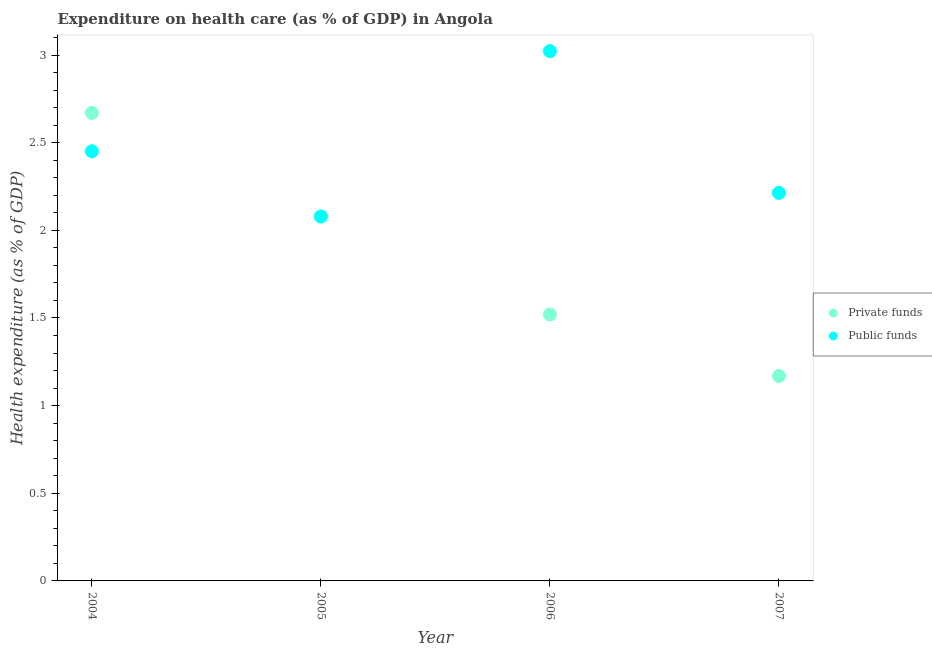How many different coloured dotlines are there?
Offer a very short reply. 2. What is the amount of private funds spent in healthcare in 2007?
Provide a succinct answer. 1.17. Across all years, what is the maximum amount of public funds spent in healthcare?
Make the answer very short. 3.02. Across all years, what is the minimum amount of private funds spent in healthcare?
Your answer should be very brief. 1.17. In which year was the amount of private funds spent in healthcare minimum?
Keep it short and to the point. 2007. What is the total amount of public funds spent in healthcare in the graph?
Offer a terse response. 9.77. What is the difference between the amount of private funds spent in healthcare in 2004 and that in 2005?
Give a very brief answer. 0.59. What is the difference between the amount of private funds spent in healthcare in 2007 and the amount of public funds spent in healthcare in 2004?
Keep it short and to the point. -1.28. What is the average amount of public funds spent in healthcare per year?
Keep it short and to the point. 2.44. In the year 2007, what is the difference between the amount of public funds spent in healthcare and amount of private funds spent in healthcare?
Give a very brief answer. 1.04. In how many years, is the amount of public funds spent in healthcare greater than 1.3 %?
Make the answer very short. 4. What is the ratio of the amount of public funds spent in healthcare in 2004 to that in 2005?
Your answer should be very brief. 1.18. Is the difference between the amount of public funds spent in healthcare in 2004 and 2006 greater than the difference between the amount of private funds spent in healthcare in 2004 and 2006?
Your answer should be compact. No. What is the difference between the highest and the second highest amount of private funds spent in healthcare?
Your answer should be very brief. 0.59. What is the difference between the highest and the lowest amount of private funds spent in healthcare?
Offer a very short reply. 1.5. Is the sum of the amount of public funds spent in healthcare in 2005 and 2006 greater than the maximum amount of private funds spent in healthcare across all years?
Offer a terse response. Yes. Is the amount of private funds spent in healthcare strictly less than the amount of public funds spent in healthcare over the years?
Keep it short and to the point. No. How many dotlines are there?
Offer a very short reply. 2. What is the difference between two consecutive major ticks on the Y-axis?
Offer a very short reply. 0.5. Does the graph contain grids?
Your answer should be compact. No. What is the title of the graph?
Ensure brevity in your answer.  Expenditure on health care (as % of GDP) in Angola. What is the label or title of the X-axis?
Ensure brevity in your answer.  Year. What is the label or title of the Y-axis?
Ensure brevity in your answer.  Health expenditure (as % of GDP). What is the Health expenditure (as % of GDP) in Private funds in 2004?
Your answer should be very brief. 2.67. What is the Health expenditure (as % of GDP) in Public funds in 2004?
Your answer should be compact. 2.45. What is the Health expenditure (as % of GDP) in Private funds in 2005?
Your answer should be compact. 2.08. What is the Health expenditure (as % of GDP) of Public funds in 2005?
Provide a succinct answer. 2.08. What is the Health expenditure (as % of GDP) in Private funds in 2006?
Give a very brief answer. 1.52. What is the Health expenditure (as % of GDP) of Public funds in 2006?
Your answer should be compact. 3.02. What is the Health expenditure (as % of GDP) in Private funds in 2007?
Your answer should be compact. 1.17. What is the Health expenditure (as % of GDP) in Public funds in 2007?
Provide a succinct answer. 2.21. Across all years, what is the maximum Health expenditure (as % of GDP) in Private funds?
Your answer should be compact. 2.67. Across all years, what is the maximum Health expenditure (as % of GDP) of Public funds?
Give a very brief answer. 3.02. Across all years, what is the minimum Health expenditure (as % of GDP) in Private funds?
Provide a succinct answer. 1.17. Across all years, what is the minimum Health expenditure (as % of GDP) of Public funds?
Provide a short and direct response. 2.08. What is the total Health expenditure (as % of GDP) in Private funds in the graph?
Offer a very short reply. 7.44. What is the total Health expenditure (as % of GDP) of Public funds in the graph?
Your response must be concise. 9.77. What is the difference between the Health expenditure (as % of GDP) of Private funds in 2004 and that in 2005?
Provide a short and direct response. 0.59. What is the difference between the Health expenditure (as % of GDP) of Public funds in 2004 and that in 2005?
Your answer should be very brief. 0.37. What is the difference between the Health expenditure (as % of GDP) in Private funds in 2004 and that in 2006?
Keep it short and to the point. 1.15. What is the difference between the Health expenditure (as % of GDP) of Public funds in 2004 and that in 2006?
Your answer should be very brief. -0.57. What is the difference between the Health expenditure (as % of GDP) in Private funds in 2004 and that in 2007?
Offer a very short reply. 1.5. What is the difference between the Health expenditure (as % of GDP) in Public funds in 2004 and that in 2007?
Your response must be concise. 0.24. What is the difference between the Health expenditure (as % of GDP) in Private funds in 2005 and that in 2006?
Make the answer very short. 0.56. What is the difference between the Health expenditure (as % of GDP) of Public funds in 2005 and that in 2006?
Provide a succinct answer. -0.94. What is the difference between the Health expenditure (as % of GDP) of Private funds in 2005 and that in 2007?
Provide a short and direct response. 0.91. What is the difference between the Health expenditure (as % of GDP) of Public funds in 2005 and that in 2007?
Your response must be concise. -0.13. What is the difference between the Health expenditure (as % of GDP) in Private funds in 2006 and that in 2007?
Provide a short and direct response. 0.35. What is the difference between the Health expenditure (as % of GDP) in Public funds in 2006 and that in 2007?
Provide a short and direct response. 0.81. What is the difference between the Health expenditure (as % of GDP) in Private funds in 2004 and the Health expenditure (as % of GDP) in Public funds in 2005?
Your answer should be compact. 0.59. What is the difference between the Health expenditure (as % of GDP) of Private funds in 2004 and the Health expenditure (as % of GDP) of Public funds in 2006?
Ensure brevity in your answer.  -0.35. What is the difference between the Health expenditure (as % of GDP) of Private funds in 2004 and the Health expenditure (as % of GDP) of Public funds in 2007?
Your answer should be compact. 0.46. What is the difference between the Health expenditure (as % of GDP) of Private funds in 2005 and the Health expenditure (as % of GDP) of Public funds in 2006?
Provide a succinct answer. -0.94. What is the difference between the Health expenditure (as % of GDP) of Private funds in 2005 and the Health expenditure (as % of GDP) of Public funds in 2007?
Make the answer very short. -0.13. What is the difference between the Health expenditure (as % of GDP) in Private funds in 2006 and the Health expenditure (as % of GDP) in Public funds in 2007?
Your answer should be compact. -0.69. What is the average Health expenditure (as % of GDP) in Private funds per year?
Make the answer very short. 1.86. What is the average Health expenditure (as % of GDP) of Public funds per year?
Offer a very short reply. 2.44. In the year 2004, what is the difference between the Health expenditure (as % of GDP) of Private funds and Health expenditure (as % of GDP) of Public funds?
Provide a short and direct response. 0.22. In the year 2006, what is the difference between the Health expenditure (as % of GDP) of Private funds and Health expenditure (as % of GDP) of Public funds?
Provide a succinct answer. -1.5. In the year 2007, what is the difference between the Health expenditure (as % of GDP) of Private funds and Health expenditure (as % of GDP) of Public funds?
Your response must be concise. -1.04. What is the ratio of the Health expenditure (as % of GDP) in Private funds in 2004 to that in 2005?
Your response must be concise. 1.28. What is the ratio of the Health expenditure (as % of GDP) of Public funds in 2004 to that in 2005?
Provide a short and direct response. 1.18. What is the ratio of the Health expenditure (as % of GDP) of Private funds in 2004 to that in 2006?
Make the answer very short. 1.76. What is the ratio of the Health expenditure (as % of GDP) of Public funds in 2004 to that in 2006?
Provide a short and direct response. 0.81. What is the ratio of the Health expenditure (as % of GDP) in Private funds in 2004 to that in 2007?
Ensure brevity in your answer.  2.28. What is the ratio of the Health expenditure (as % of GDP) of Public funds in 2004 to that in 2007?
Ensure brevity in your answer.  1.11. What is the ratio of the Health expenditure (as % of GDP) of Private funds in 2005 to that in 2006?
Offer a very short reply. 1.37. What is the ratio of the Health expenditure (as % of GDP) of Public funds in 2005 to that in 2006?
Provide a succinct answer. 0.69. What is the ratio of the Health expenditure (as % of GDP) in Private funds in 2005 to that in 2007?
Offer a terse response. 1.78. What is the ratio of the Health expenditure (as % of GDP) of Public funds in 2005 to that in 2007?
Give a very brief answer. 0.94. What is the ratio of the Health expenditure (as % of GDP) in Private funds in 2006 to that in 2007?
Keep it short and to the point. 1.3. What is the ratio of the Health expenditure (as % of GDP) in Public funds in 2006 to that in 2007?
Give a very brief answer. 1.37. What is the difference between the highest and the second highest Health expenditure (as % of GDP) in Private funds?
Your answer should be very brief. 0.59. What is the difference between the highest and the lowest Health expenditure (as % of GDP) in Private funds?
Give a very brief answer. 1.5. What is the difference between the highest and the lowest Health expenditure (as % of GDP) in Public funds?
Provide a succinct answer. 0.94. 